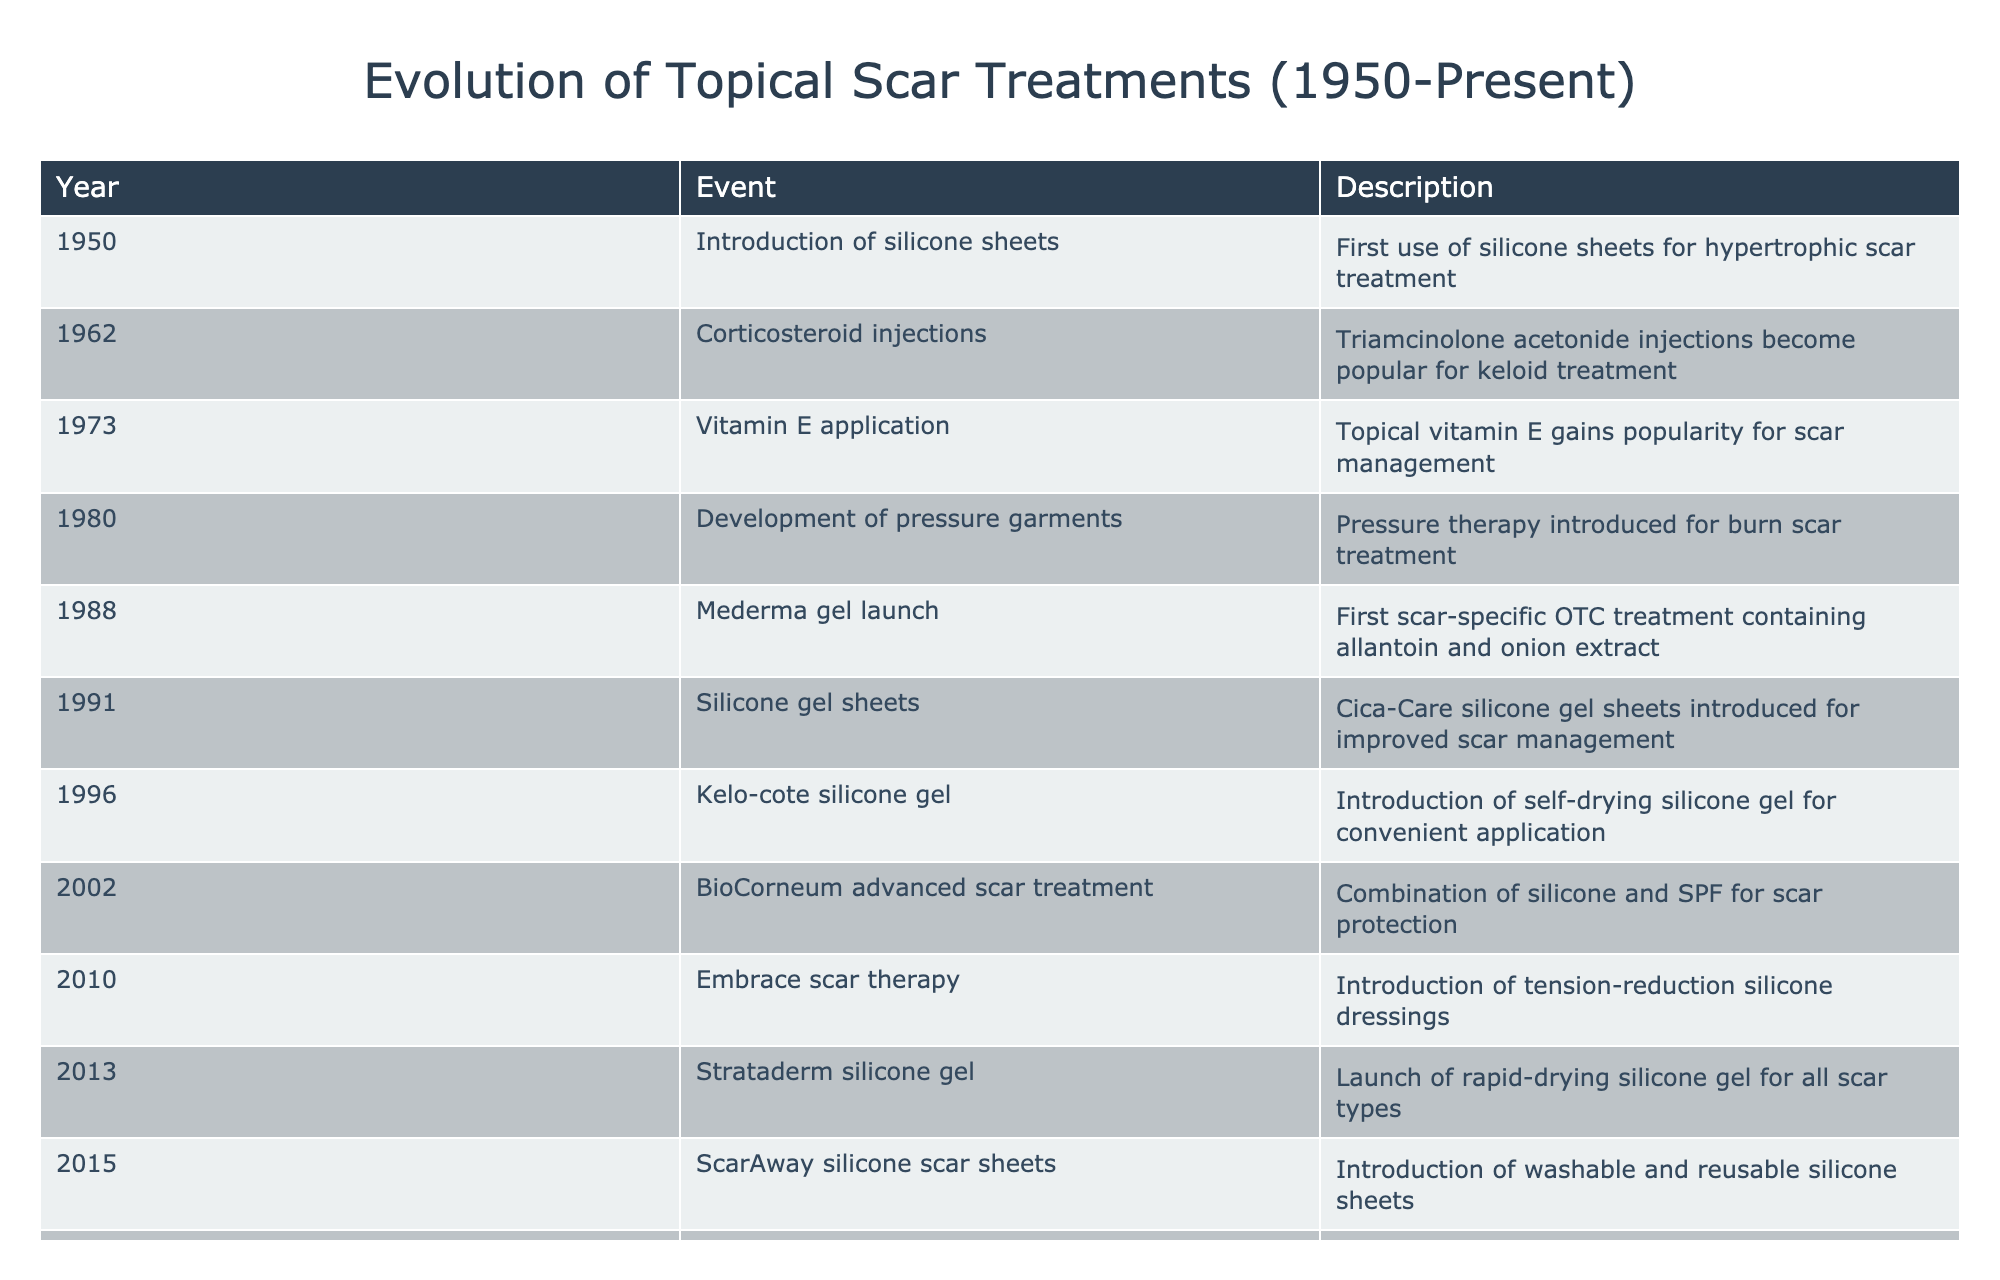What year was the first use of silicone sheets for scar treatment? The table shows "1950" as the year for the introduction of silicone sheets, which is the first event listed. Therefore, the first use of silicone sheets for scar treatment occurred in 1950.
Answer: 1950 Which treatment was launched in 2013? By looking at the table, the event listed for 2013 is the launch of "Strataderm silicone gel," which indicates that this particular treatment was introduced that year.
Answer: Strataderm silicone gel How many significant developments in topical scar treatments occurred between 2000 and 2010? The table lists the events for each year. The relevant treatments from 2000 to 2010 are BioCorneum advanced scar treatment in 2002 and Embrace scar therapy in 2010. This gives us a total of 2 significant developments during that period.
Answer: 2 Was the development of pressure garments introduced before or after 1980? Referring to the table, the event for developing pressure garments is listed under 1980, making it clear that this development occurred in or before that year. The answer is that it was introduced in 1980, so the event was not after.
Answer: Before Which topical scar treatment introduced a combination of silicone and SPF? The table indicates that BioCorneum advanced scar treatment was introduced in 2002 and specifically mentions its combination of silicone and SPF for scar protection.
Answer: BioCorneum advanced scar treatment What is the average number of years between significant events listed in the table? To calculate the average number of years between events, we first determine the time span from 1950 to 2021, which is 71 years, and there are 12 events listed (including both endpoints). To find the average, we compute 71 divided by 11 (the number of intervals between events), resulting in approximately 6.45 years between events.
Answer: 6.45 Was Mederma gel the first OTC treatment for scars? According to the table, Mederma gel was launched in 1988, and it is specified as the first scar-specific OTC treatment. This indicates that, yes, Mederma gel was indeed the first OTC treatment for scars.
Answer: Yes How many treatments were introduced in the 1990s? Looking at the table, there were three treatments introduced in the 1990s: Mederma gel in 1988, silicone gel sheets in 1991, and Kelo-cote silicone gel in 1996. Thus, there are a total of 3 treatments introduced in this decade.
Answer: 3 What type of treatment was launched in 2017 and what is unique about it? The event from 2017 in the table indicates the launch of Skinuva scar formula. This treatment is unique because it is a growth factor-based scar treatment, contrasting with earlier silicone-based treatments.
Answer: Skinuva scar formula; unique because it's growth factor-based 